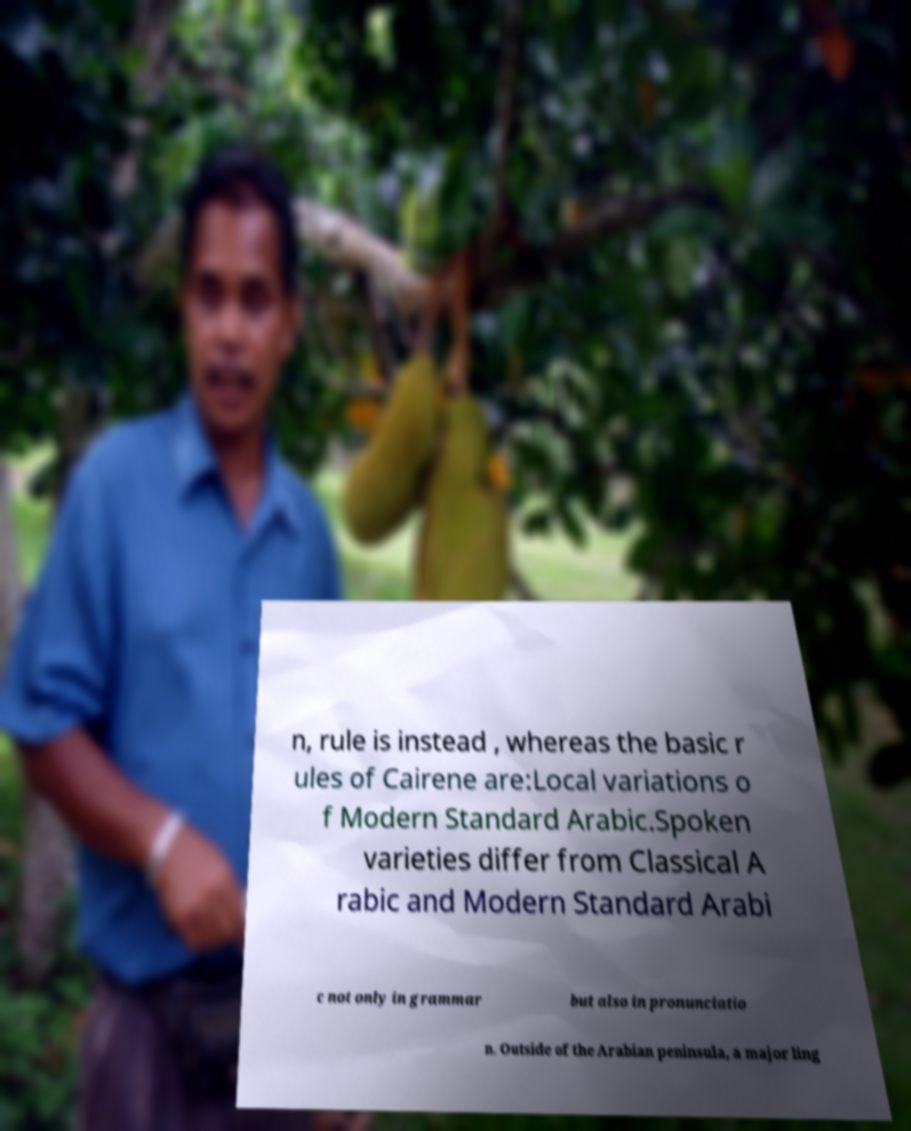Please read and relay the text visible in this image. What does it say? n, rule is instead , whereas the basic r ules of Cairene are:Local variations o f Modern Standard Arabic.Spoken varieties differ from Classical A rabic and Modern Standard Arabi c not only in grammar but also in pronunciatio n. Outside of the Arabian peninsula, a major ling 